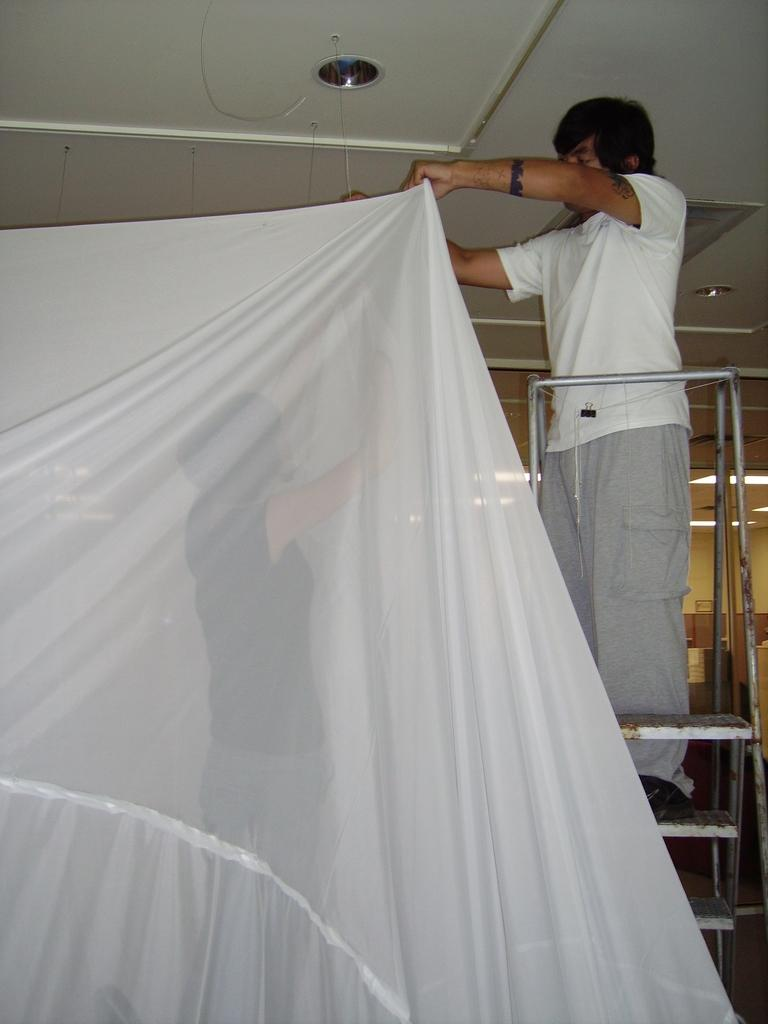What is the man doing in the image? The man is standing on metal stairs in the image. What is the man holding in the image? The man is holding a cloth in the image. Can you describe the woman in the image? There is a woman in the image, but no specific details about her appearance or actions are provided. What type of setting is depicted in the image? The image appears to be an inner view of a room. How many babies are crawling on the floor in the image? There are no babies present in the image; it only features a man standing on metal stairs, a woman, and a cloth. What letters are being spied on in the image? There are no letters or spying activities depicted in the image. 